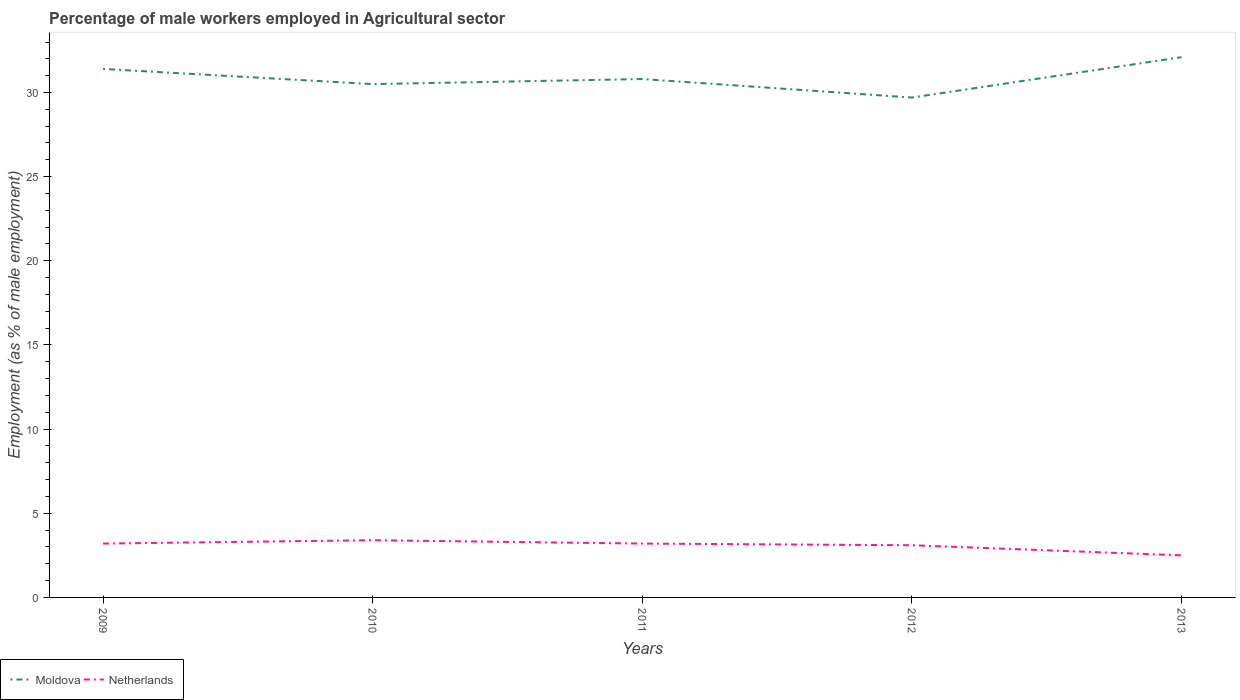Does the line corresponding to Netherlands intersect with the line corresponding to Moldova?
Ensure brevity in your answer.  No. Is the number of lines equal to the number of legend labels?
Ensure brevity in your answer.  Yes. In which year was the percentage of male workers employed in Agricultural sector in Moldova maximum?
Your answer should be very brief. 2012. What is the total percentage of male workers employed in Agricultural sector in Moldova in the graph?
Your response must be concise. 0.9. What is the difference between the highest and the second highest percentage of male workers employed in Agricultural sector in Moldova?
Give a very brief answer. 2.4. What is the difference between the highest and the lowest percentage of male workers employed in Agricultural sector in Netherlands?
Your answer should be compact. 4. How many lines are there?
Provide a succinct answer. 2. How many years are there in the graph?
Give a very brief answer. 5. What is the difference between two consecutive major ticks on the Y-axis?
Your answer should be compact. 5. Where does the legend appear in the graph?
Your answer should be compact. Bottom left. What is the title of the graph?
Offer a very short reply. Percentage of male workers employed in Agricultural sector. What is the label or title of the X-axis?
Keep it short and to the point. Years. What is the label or title of the Y-axis?
Provide a succinct answer. Employment (as % of male employment). What is the Employment (as % of male employment) in Moldova in 2009?
Make the answer very short. 31.4. What is the Employment (as % of male employment) of Netherlands in 2009?
Your response must be concise. 3.2. What is the Employment (as % of male employment) of Moldova in 2010?
Provide a short and direct response. 30.5. What is the Employment (as % of male employment) of Netherlands in 2010?
Keep it short and to the point. 3.4. What is the Employment (as % of male employment) of Moldova in 2011?
Your answer should be compact. 30.8. What is the Employment (as % of male employment) in Netherlands in 2011?
Make the answer very short. 3.2. What is the Employment (as % of male employment) in Moldova in 2012?
Offer a terse response. 29.7. What is the Employment (as % of male employment) of Netherlands in 2012?
Provide a short and direct response. 3.1. What is the Employment (as % of male employment) of Moldova in 2013?
Give a very brief answer. 32.1. Across all years, what is the maximum Employment (as % of male employment) in Moldova?
Ensure brevity in your answer.  32.1. Across all years, what is the maximum Employment (as % of male employment) in Netherlands?
Make the answer very short. 3.4. Across all years, what is the minimum Employment (as % of male employment) in Moldova?
Make the answer very short. 29.7. Across all years, what is the minimum Employment (as % of male employment) of Netherlands?
Ensure brevity in your answer.  2.5. What is the total Employment (as % of male employment) of Moldova in the graph?
Ensure brevity in your answer.  154.5. What is the difference between the Employment (as % of male employment) of Moldova in 2009 and that in 2011?
Give a very brief answer. 0.6. What is the difference between the Employment (as % of male employment) in Moldova in 2009 and that in 2013?
Offer a terse response. -0.7. What is the difference between the Employment (as % of male employment) in Netherlands in 2009 and that in 2013?
Ensure brevity in your answer.  0.7. What is the difference between the Employment (as % of male employment) of Moldova in 2010 and that in 2012?
Your response must be concise. 0.8. What is the difference between the Employment (as % of male employment) of Netherlands in 2010 and that in 2012?
Give a very brief answer. 0.3. What is the difference between the Employment (as % of male employment) of Moldova in 2010 and that in 2013?
Keep it short and to the point. -1.6. What is the difference between the Employment (as % of male employment) of Moldova in 2011 and that in 2013?
Provide a short and direct response. -1.3. What is the difference between the Employment (as % of male employment) of Moldova in 2012 and that in 2013?
Provide a short and direct response. -2.4. What is the difference between the Employment (as % of male employment) of Netherlands in 2012 and that in 2013?
Provide a short and direct response. 0.6. What is the difference between the Employment (as % of male employment) of Moldova in 2009 and the Employment (as % of male employment) of Netherlands in 2011?
Your answer should be very brief. 28.2. What is the difference between the Employment (as % of male employment) in Moldova in 2009 and the Employment (as % of male employment) in Netherlands in 2012?
Provide a short and direct response. 28.3. What is the difference between the Employment (as % of male employment) in Moldova in 2009 and the Employment (as % of male employment) in Netherlands in 2013?
Your answer should be compact. 28.9. What is the difference between the Employment (as % of male employment) in Moldova in 2010 and the Employment (as % of male employment) in Netherlands in 2011?
Keep it short and to the point. 27.3. What is the difference between the Employment (as % of male employment) of Moldova in 2010 and the Employment (as % of male employment) of Netherlands in 2012?
Provide a succinct answer. 27.4. What is the difference between the Employment (as % of male employment) of Moldova in 2010 and the Employment (as % of male employment) of Netherlands in 2013?
Offer a very short reply. 28. What is the difference between the Employment (as % of male employment) of Moldova in 2011 and the Employment (as % of male employment) of Netherlands in 2012?
Your response must be concise. 27.7. What is the difference between the Employment (as % of male employment) of Moldova in 2011 and the Employment (as % of male employment) of Netherlands in 2013?
Offer a very short reply. 28.3. What is the difference between the Employment (as % of male employment) in Moldova in 2012 and the Employment (as % of male employment) in Netherlands in 2013?
Provide a succinct answer. 27.2. What is the average Employment (as % of male employment) of Moldova per year?
Your answer should be very brief. 30.9. What is the average Employment (as % of male employment) of Netherlands per year?
Give a very brief answer. 3.08. In the year 2009, what is the difference between the Employment (as % of male employment) of Moldova and Employment (as % of male employment) of Netherlands?
Your answer should be very brief. 28.2. In the year 2010, what is the difference between the Employment (as % of male employment) in Moldova and Employment (as % of male employment) in Netherlands?
Offer a terse response. 27.1. In the year 2011, what is the difference between the Employment (as % of male employment) of Moldova and Employment (as % of male employment) of Netherlands?
Offer a terse response. 27.6. In the year 2012, what is the difference between the Employment (as % of male employment) of Moldova and Employment (as % of male employment) of Netherlands?
Your response must be concise. 26.6. In the year 2013, what is the difference between the Employment (as % of male employment) in Moldova and Employment (as % of male employment) in Netherlands?
Provide a short and direct response. 29.6. What is the ratio of the Employment (as % of male employment) of Moldova in 2009 to that in 2010?
Provide a succinct answer. 1.03. What is the ratio of the Employment (as % of male employment) in Moldova in 2009 to that in 2011?
Offer a terse response. 1.02. What is the ratio of the Employment (as % of male employment) in Moldova in 2009 to that in 2012?
Your answer should be very brief. 1.06. What is the ratio of the Employment (as % of male employment) in Netherlands in 2009 to that in 2012?
Keep it short and to the point. 1.03. What is the ratio of the Employment (as % of male employment) of Moldova in 2009 to that in 2013?
Offer a very short reply. 0.98. What is the ratio of the Employment (as % of male employment) of Netherlands in 2009 to that in 2013?
Offer a terse response. 1.28. What is the ratio of the Employment (as % of male employment) of Moldova in 2010 to that in 2011?
Make the answer very short. 0.99. What is the ratio of the Employment (as % of male employment) of Moldova in 2010 to that in 2012?
Your answer should be very brief. 1.03. What is the ratio of the Employment (as % of male employment) in Netherlands in 2010 to that in 2012?
Offer a terse response. 1.1. What is the ratio of the Employment (as % of male employment) in Moldova in 2010 to that in 2013?
Provide a succinct answer. 0.95. What is the ratio of the Employment (as % of male employment) in Netherlands in 2010 to that in 2013?
Give a very brief answer. 1.36. What is the ratio of the Employment (as % of male employment) of Moldova in 2011 to that in 2012?
Your answer should be very brief. 1.04. What is the ratio of the Employment (as % of male employment) in Netherlands in 2011 to that in 2012?
Provide a short and direct response. 1.03. What is the ratio of the Employment (as % of male employment) of Moldova in 2011 to that in 2013?
Your answer should be compact. 0.96. What is the ratio of the Employment (as % of male employment) of Netherlands in 2011 to that in 2013?
Give a very brief answer. 1.28. What is the ratio of the Employment (as % of male employment) of Moldova in 2012 to that in 2013?
Your answer should be very brief. 0.93. What is the ratio of the Employment (as % of male employment) in Netherlands in 2012 to that in 2013?
Give a very brief answer. 1.24. What is the difference between the highest and the second highest Employment (as % of male employment) of Moldova?
Your answer should be very brief. 0.7. 